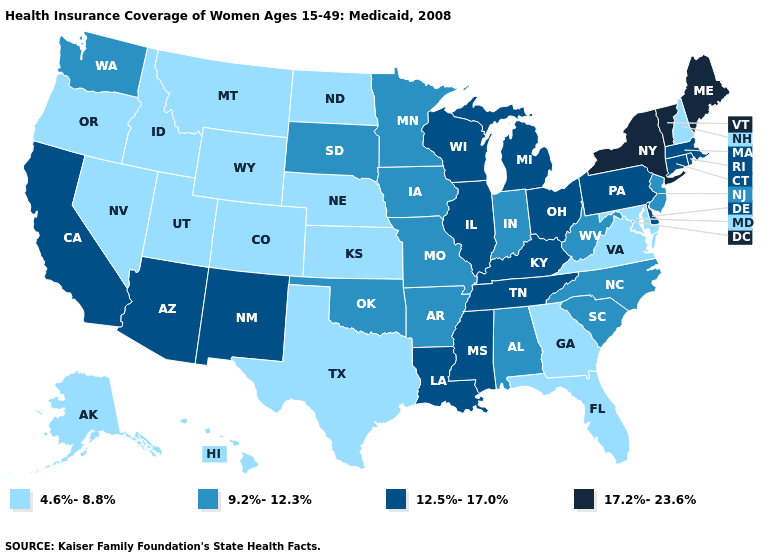What is the value of New Hampshire?
Give a very brief answer. 4.6%-8.8%. Does Connecticut have a lower value than Maine?
Short answer required. Yes. Does Missouri have the same value as New Jersey?
Quick response, please. Yes. What is the value of New Mexico?
Write a very short answer. 12.5%-17.0%. What is the value of Oklahoma?
Keep it brief. 9.2%-12.3%. Does New York have the same value as Maine?
Answer briefly. Yes. What is the value of Utah?
Short answer required. 4.6%-8.8%. Name the states that have a value in the range 4.6%-8.8%?
Quick response, please. Alaska, Colorado, Florida, Georgia, Hawaii, Idaho, Kansas, Maryland, Montana, Nebraska, Nevada, New Hampshire, North Dakota, Oregon, Texas, Utah, Virginia, Wyoming. Name the states that have a value in the range 17.2%-23.6%?
Short answer required. Maine, New York, Vermont. Which states have the lowest value in the USA?
Quick response, please. Alaska, Colorado, Florida, Georgia, Hawaii, Idaho, Kansas, Maryland, Montana, Nebraska, Nevada, New Hampshire, North Dakota, Oregon, Texas, Utah, Virginia, Wyoming. What is the highest value in states that border Indiana?
Answer briefly. 12.5%-17.0%. What is the lowest value in the USA?
Keep it brief. 4.6%-8.8%. Name the states that have a value in the range 12.5%-17.0%?
Short answer required. Arizona, California, Connecticut, Delaware, Illinois, Kentucky, Louisiana, Massachusetts, Michigan, Mississippi, New Mexico, Ohio, Pennsylvania, Rhode Island, Tennessee, Wisconsin. Name the states that have a value in the range 12.5%-17.0%?
Give a very brief answer. Arizona, California, Connecticut, Delaware, Illinois, Kentucky, Louisiana, Massachusetts, Michigan, Mississippi, New Mexico, Ohio, Pennsylvania, Rhode Island, Tennessee, Wisconsin. Is the legend a continuous bar?
Keep it brief. No. 